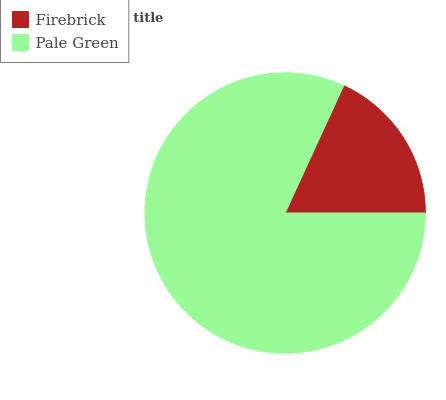Is Firebrick the minimum?
Answer yes or no. Yes. Is Pale Green the maximum?
Answer yes or no. Yes. Is Pale Green the minimum?
Answer yes or no. No. Is Pale Green greater than Firebrick?
Answer yes or no. Yes. Is Firebrick less than Pale Green?
Answer yes or no. Yes. Is Firebrick greater than Pale Green?
Answer yes or no. No. Is Pale Green less than Firebrick?
Answer yes or no. No. Is Pale Green the high median?
Answer yes or no. Yes. Is Firebrick the low median?
Answer yes or no. Yes. Is Firebrick the high median?
Answer yes or no. No. Is Pale Green the low median?
Answer yes or no. No. 